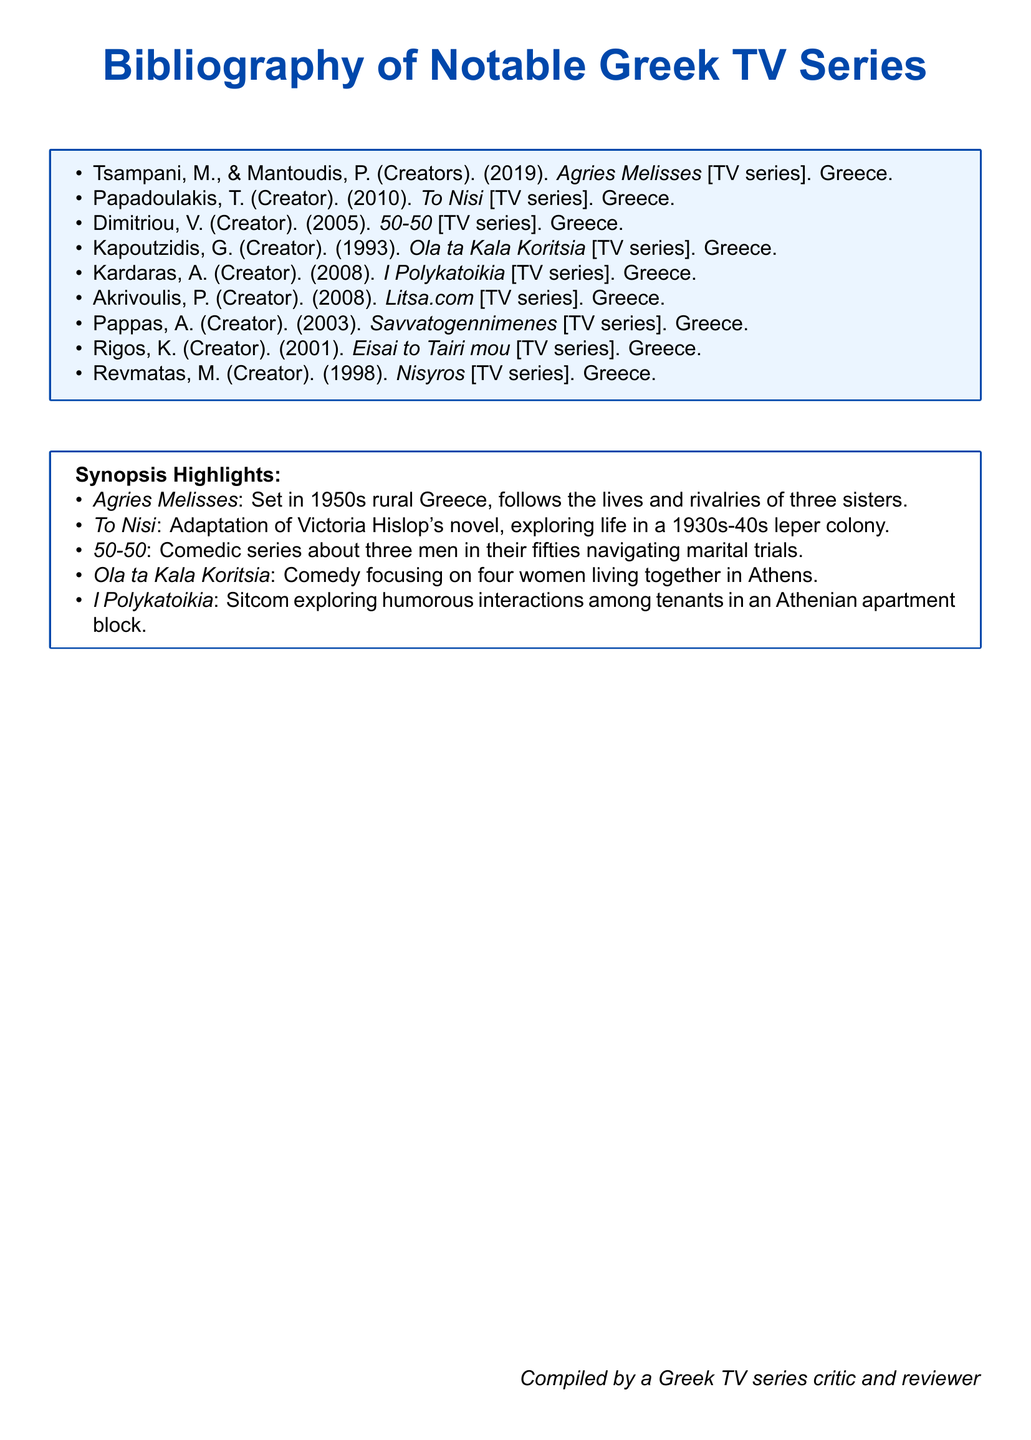What year was Agries Melisses released? The document lists Agries Melisses as released in 2019.
Answer: 2019 Who created To Nisi? The document credits Papadoulakis, T. as the creator of To Nisi.
Answer: Papadoulakis, T What is the synopsis of I Polykatoikia? The document describes I Polykatoikia as a sitcom exploring humorous interactions among tenants in an Athenian apartment block.
Answer: Sitcom exploring humorous interactions among tenants in an Athenian apartment block Which two series were released in 2008? Both I Polykatoikia and Litsa.com were released in 2008 according to the document.
Answer: I Polykatoikia, Litsa.com How many TV series are mentioned in the bibliography? The document lists a total of nine notable Greek TV series.
Answer: Nine 